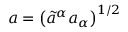<formula> <loc_0><loc_0><loc_500><loc_500>a = \left ( \tilde { a } ^ { \alpha } a _ { \alpha } \right ) ^ { 1 / 2 }</formula> 